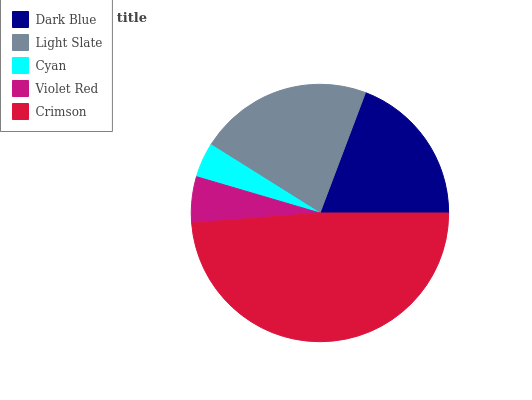Is Cyan the minimum?
Answer yes or no. Yes. Is Crimson the maximum?
Answer yes or no. Yes. Is Light Slate the minimum?
Answer yes or no. No. Is Light Slate the maximum?
Answer yes or no. No. Is Light Slate greater than Dark Blue?
Answer yes or no. Yes. Is Dark Blue less than Light Slate?
Answer yes or no. Yes. Is Dark Blue greater than Light Slate?
Answer yes or no. No. Is Light Slate less than Dark Blue?
Answer yes or no. No. Is Dark Blue the high median?
Answer yes or no. Yes. Is Dark Blue the low median?
Answer yes or no. Yes. Is Crimson the high median?
Answer yes or no. No. Is Light Slate the low median?
Answer yes or no. No. 